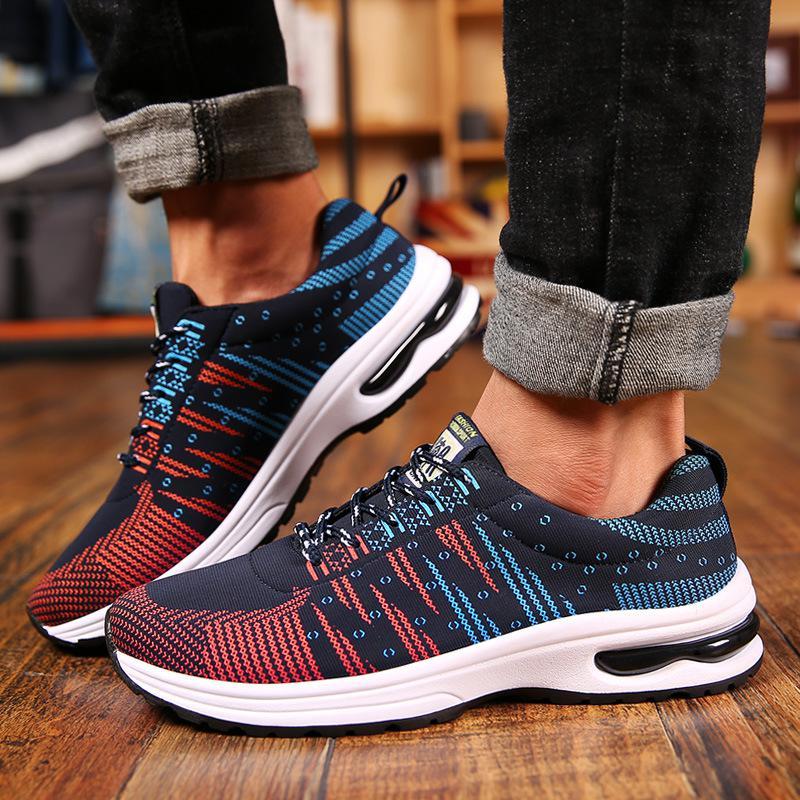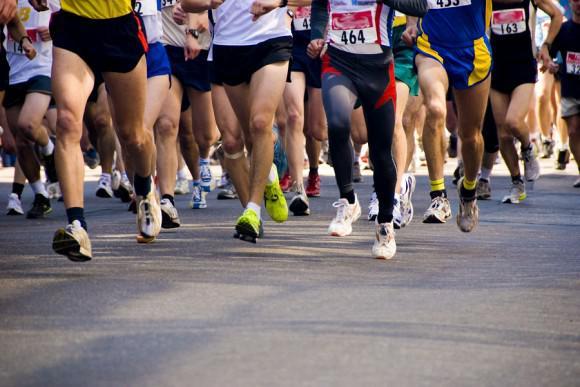The first image is the image on the left, the second image is the image on the right. Evaluate the accuracy of this statement regarding the images: "There are two shoes in the left image". Is it true? Answer yes or no. Yes. 